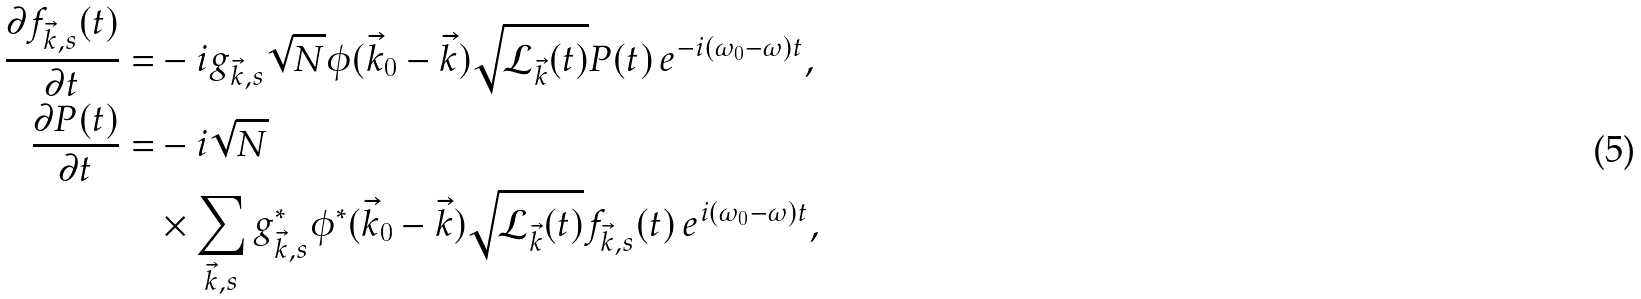<formula> <loc_0><loc_0><loc_500><loc_500>\frac { \partial f _ { \vec { k } , s } ( t ) } { \partial t } = & - i g _ { \vec { k } , s } \sqrt { N } \phi ( \vec { k } _ { 0 } - \vec { k } ) \sqrt { \mathcal { L } _ { \vec { k } } ( t ) } P ( t ) { \, e } ^ { - i ( \omega _ { 0 } - \omega ) t } , \\ \frac { \partial P ( t ) } { \partial t } = & - i \sqrt { N } \\ & \times \sum _ { \vec { k } , s } g ^ { \ast } _ { \vec { k } , s } \phi ^ { \ast } ( \vec { k } _ { 0 } - \vec { k } ) \sqrt { \mathcal { L } _ { \vec { k } } ( t ) } f _ { \vec { k } , s } ( t ) { \, e } ^ { i ( \omega _ { 0 } - \omega ) t } ,</formula> 